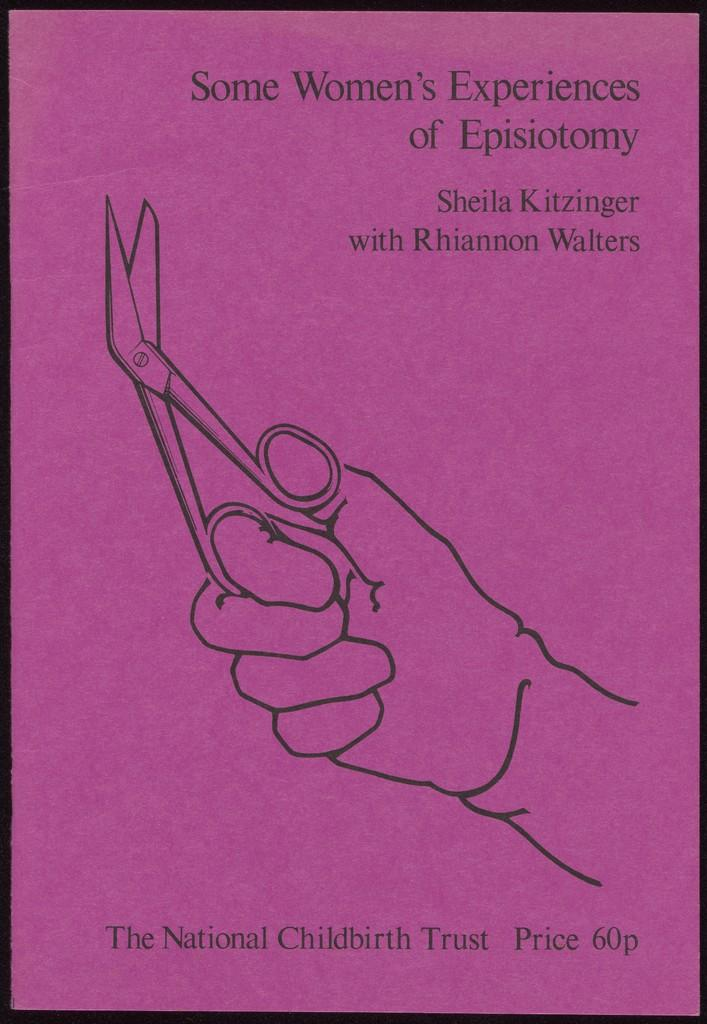<image>
Give a short and clear explanation of the subsequent image. A pink book with the words Women's Experiences of Episiotomy. 